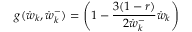Convert formula to latex. <formula><loc_0><loc_0><loc_500><loc_500>g ( \dot { w } _ { k } , \dot { w } _ { k } ^ { - } ) = \left ( 1 - \frac { 3 ( 1 - r ) } { 2 \dot { w } _ { k } ^ { - } } \dot { w } _ { k } \right )</formula> 